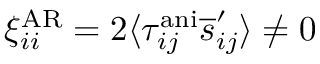Convert formula to latex. <formula><loc_0><loc_0><loc_500><loc_500>\xi _ { i i } ^ { A R } = 2 \langle \tau _ { i j } ^ { a n i } \overline { s } _ { i j } ^ { \prime } \rangle \neq 0</formula> 